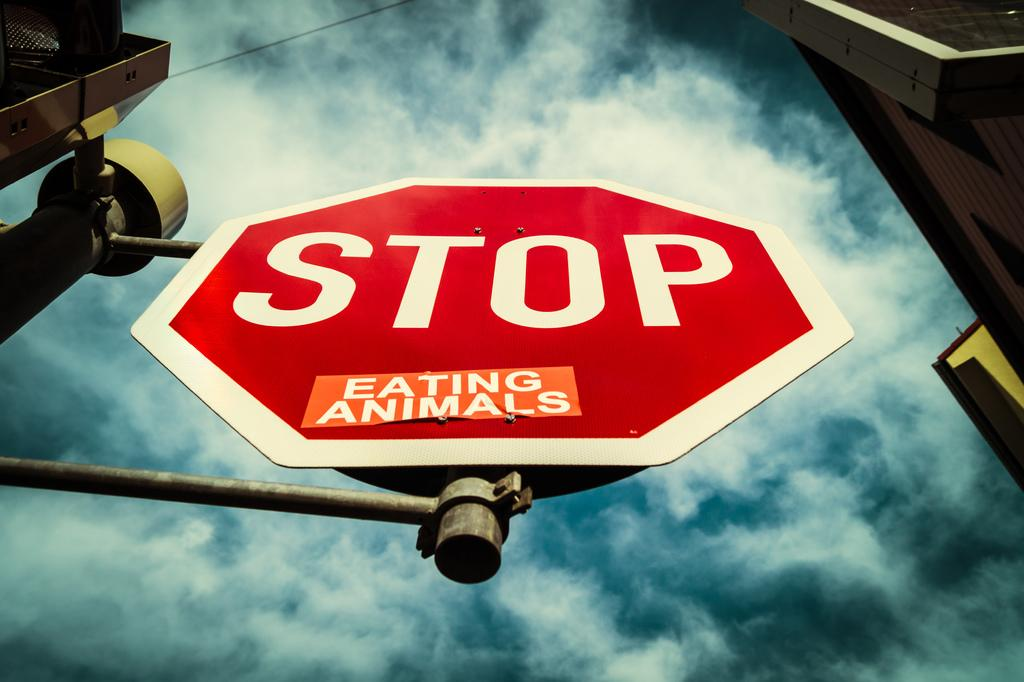<image>
Render a clear and concise summary of the photo. A stop sign with a sticker that says Eating Animals on it. 